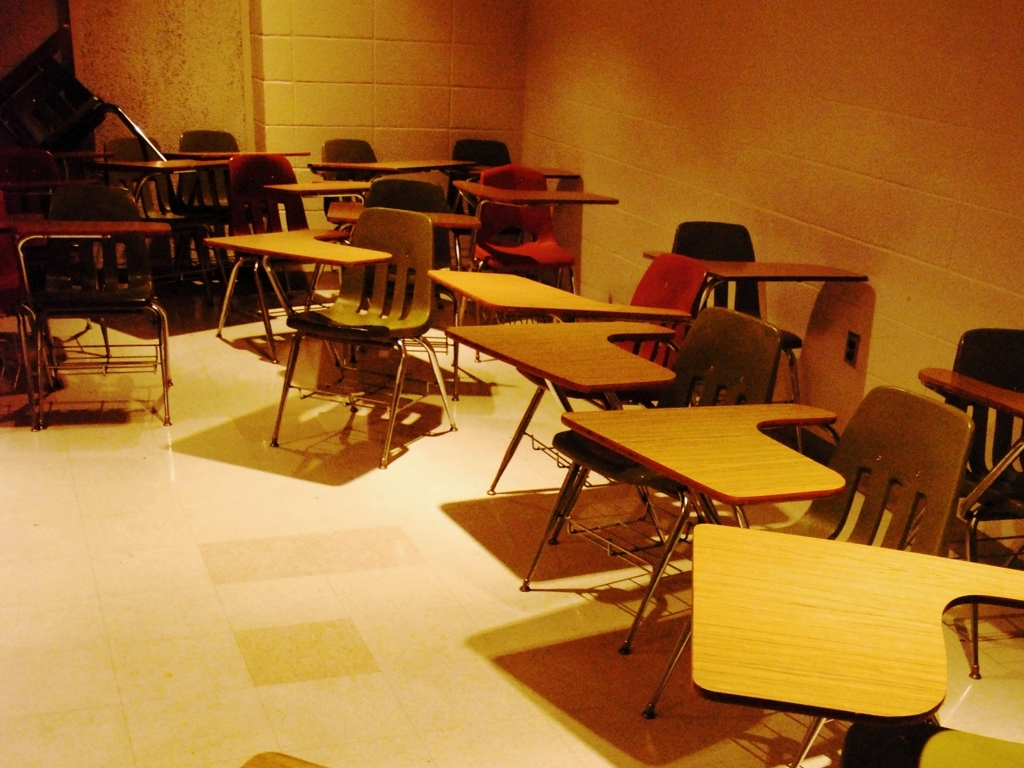Describe the lighting in this classroom. The lighting in the classroom appears to be dim, which might not be optimal for reading or writing. Proper lighting is crucial for maintaining students' focus and preventing eye strain, so brighter lights or additional sources of light might improve the environment for learning purposes. 